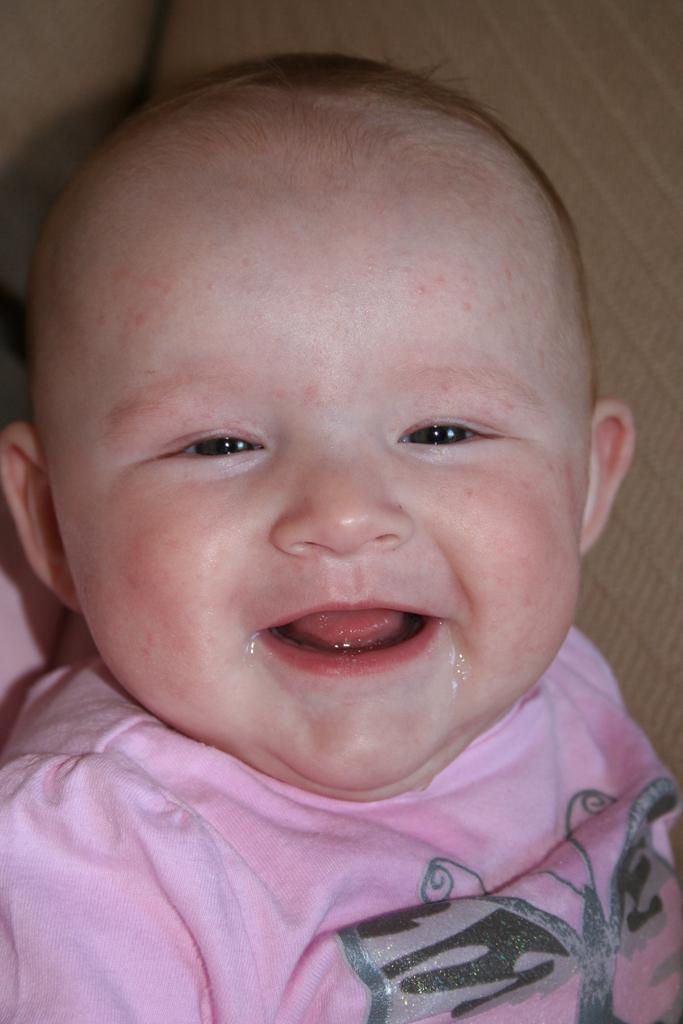What is the main subject of the image? There is a baby in the center of the image. Can you describe the baby's position or posture? The provided facts do not specify the baby's position or posture. Is there anything else in the image besides the baby? The provided facts do not mention any other objects or subjects in the image. What type of soup is being served in the image? There is no soup present in the image; it only features a baby. 